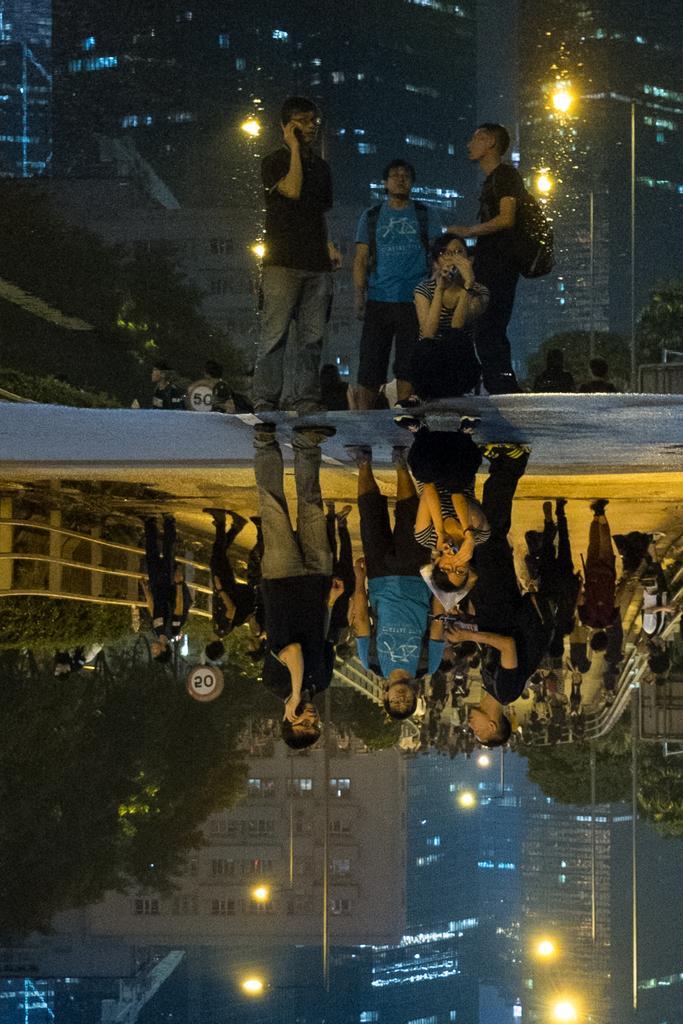Could you give a brief overview of what you see in this image? In this image I can see few persons are standing on the road, the water and on the water I can see the reflection of few persons, few trees and few buildings. In the background I can see few buildings, few trees and the sky. 